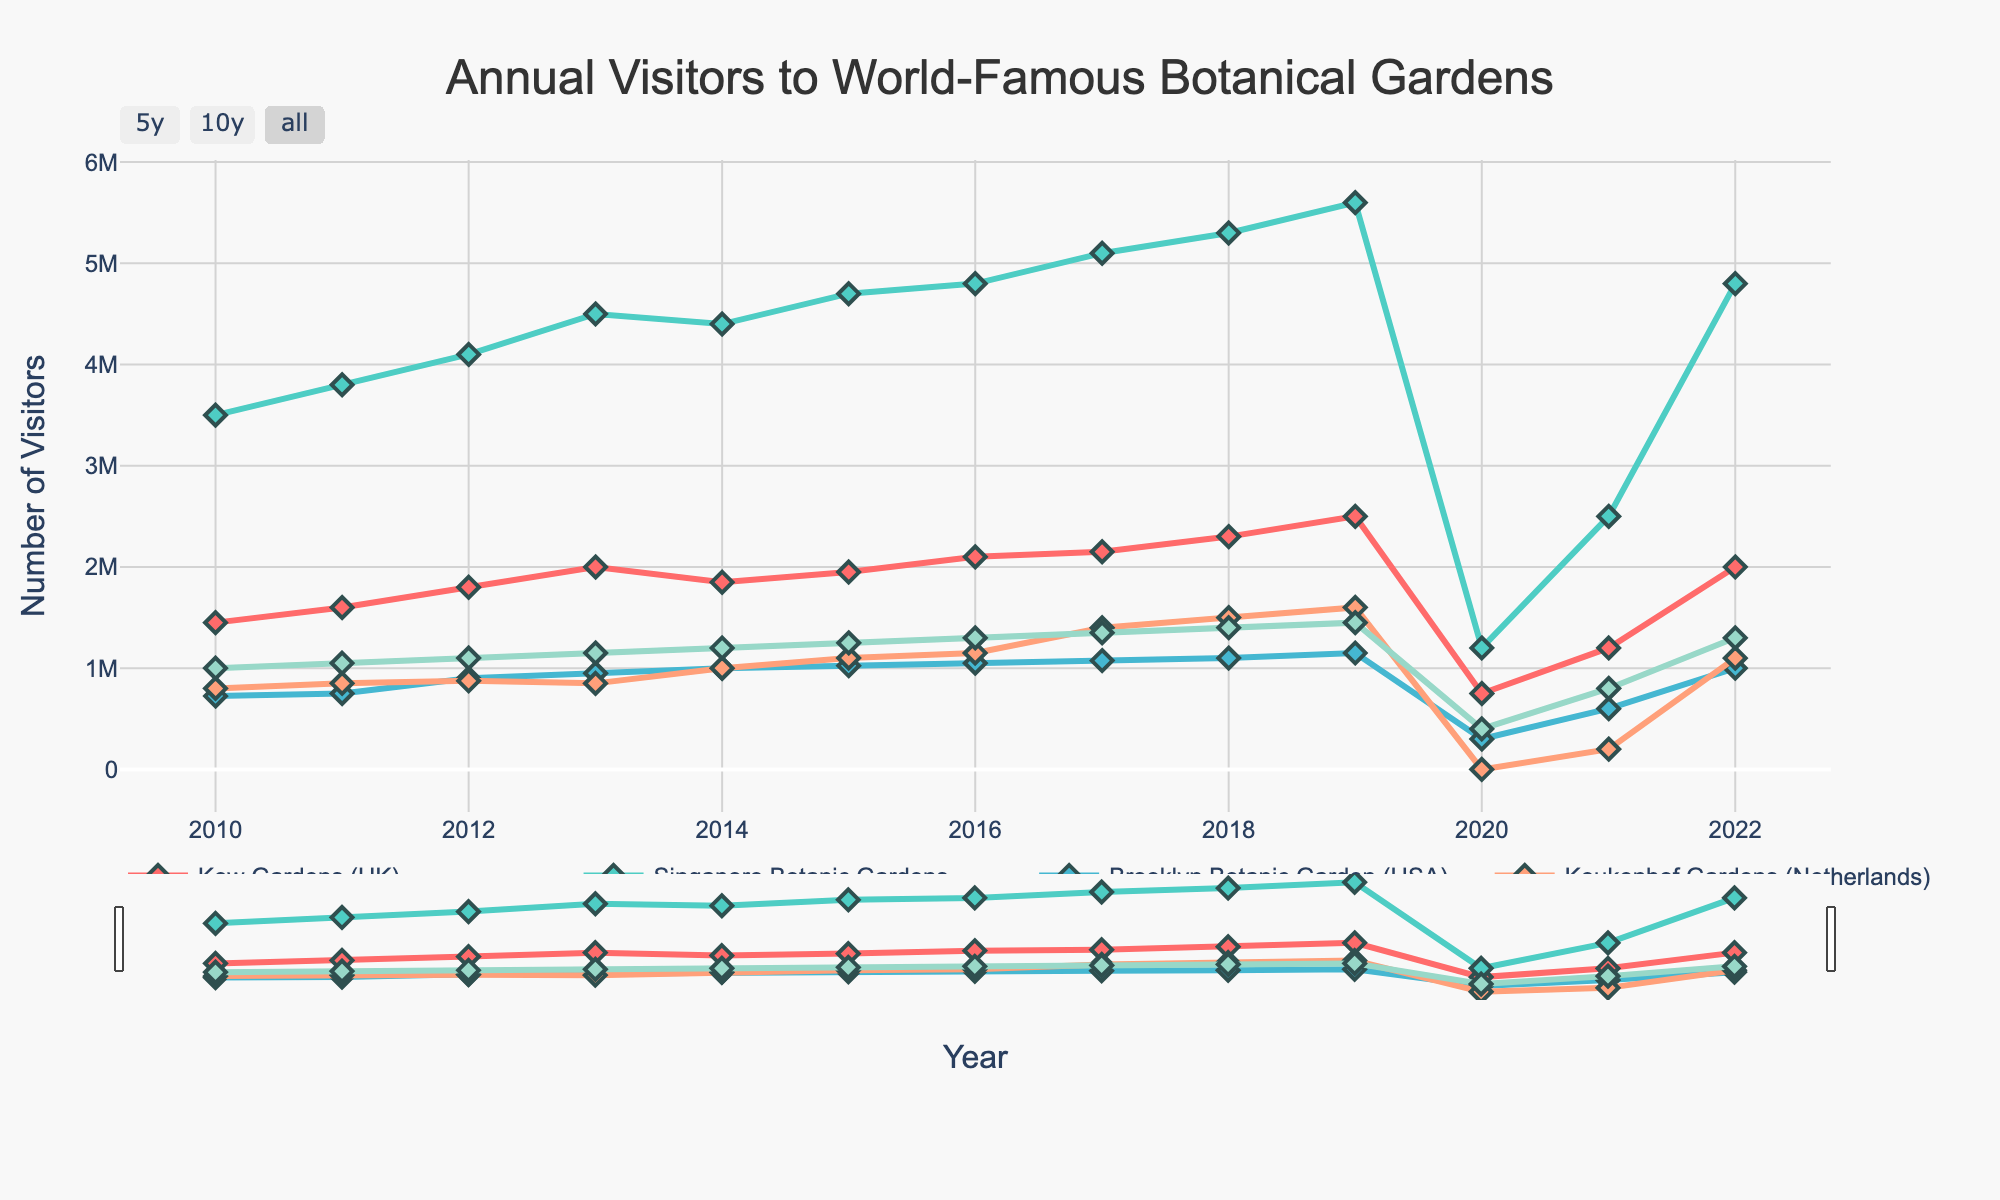Which garden had the highest number of visitors in 2019? Review the data points for 2019 and find the highest among them. For 2019, Kew Gardens had 2,500,000; Singapore Botanic Gardens, 5,600,000; Brooklyn Botanic Garden, 1,150,000; Keukenhof Gardens, 1,600,000; Butchart Gardens, 1,450,000. The highest value is 5,600,000 for Singapore Botanic Gardens.
Answer: Singapore Botanic Gardens What was the trend of visitors to Keukenhof Gardens from 2016 to 2019? Look at the data points for Keukenhof Gardens from 2016 (1,150,000), 2017 (1,400,000), 2018 (1,500,000), and 2019 (1,600,000). You can see that the number of visitors increased each year.
Answer: Increasing By how much did the number of visitors to Butchart Gardens change from 2019 to 2020? Check the data for Butchart Gardens in 2019 (1,450,000) and 2020 (400,000). Subtract the 2020 value from the 2019 value: 1,450,000 - 400,000 = 1,050,000.
Answer: 1,050,000 Which garden had a higher number of visitors in 2012: Kew Gardens or Brooklyn Botanic Garden? Compare the data points for 2012. Kew Gardens had 1,800,000 visitors, while Brooklyn Botanic Garden had 900,000. Kew Gardens had the higher number of visitors.
Answer: Kew Gardens What is the average number of visitors to Singapore Botanic Gardens from 2010 to 2015? Find the data for each year from 2010 to 2015: 3,500,000, 3,800,000, 4,100,000, 4,500,000, 4,400,000, and 4,700,000. Sum them and divide by the number of years (6). The total is 25,000,000, and the average is 25,000,000 / 6 = 4,166,667.
Answer: 4,166,667 Did the number of visitors to any garden drop to zero at any point in the given timeline? Check all data points for any value of zero. Keukenhof Gardens had 0 visitors in 2020, so yes, the number of visitors did drop to zero for that garden in that year.
Answer: Yes How did the number of visitors to Kew Gardens change between 2021 and 2022? Compare the visitor numbers for Kew Gardens in 2021 (1,200,000) and 2022 (2,000,000). The number of visitors increased by 800,000.
Answer: Increase Which garden experienced the most significant drop in visitors from 2019 to 2020, and by how much? Compare the drop in visitors for all gardens from 2019 to 2020: Kew Gardens (2,500,000 to 750,000 = 1,750,000), Singapore Botanic Gardens (5,600,000 to 1,200,000 = 4,400,000), Brooklyn Botanic Garden (1,150,000 to 300,000 = 850,000), Keukenhof Gardens (1,600,000 to 0 = 1,600,000), Butchart Gardens (1,450,000 to 400,000 = 1,050,000). Singapore Botanic Gardens had the largest drop of 4,400,000.
Answer: Singapore Botanic Gardens, 4,400,000 What was the percentage increase in visitors to Brooklyn Botanic Garden from 2020 to 2021? Look at the visitor numbers for Brooklyn Botanic Garden for 2020 (300,000) and 2021 (600,000). Calculate the percentage increase: ((600,000 - 300,000) / 300,000) * 100% = 100%.
Answer: 100% Which garden had consistently increasing visitor numbers from 2010 to 2019? Check the visitor numbers for each garden from 2010 to 2019. Only Singapore Botanic Gardens had a consistent increase every year: 3,500,000, 3,800,000, 4,100,000, 4,500,000, 4,400,000, 4,700,000, 4,800,000, 5,100,000, 5,300,000, 5,600,000.
Answer: Singapore Botanic Gardens 